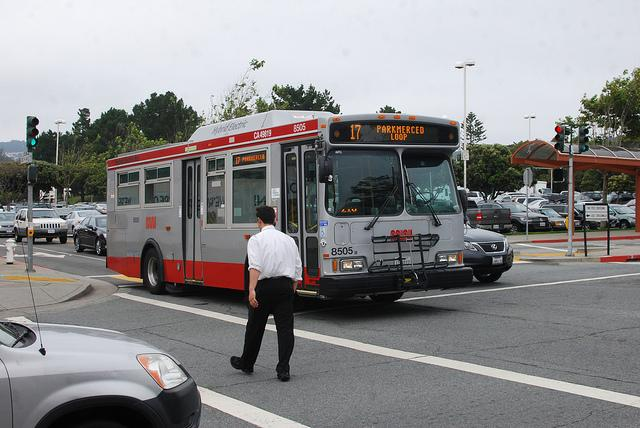After making one full circuit of their route starting from here where will this bus return? Please explain your reasoning. here. They can go back here. 